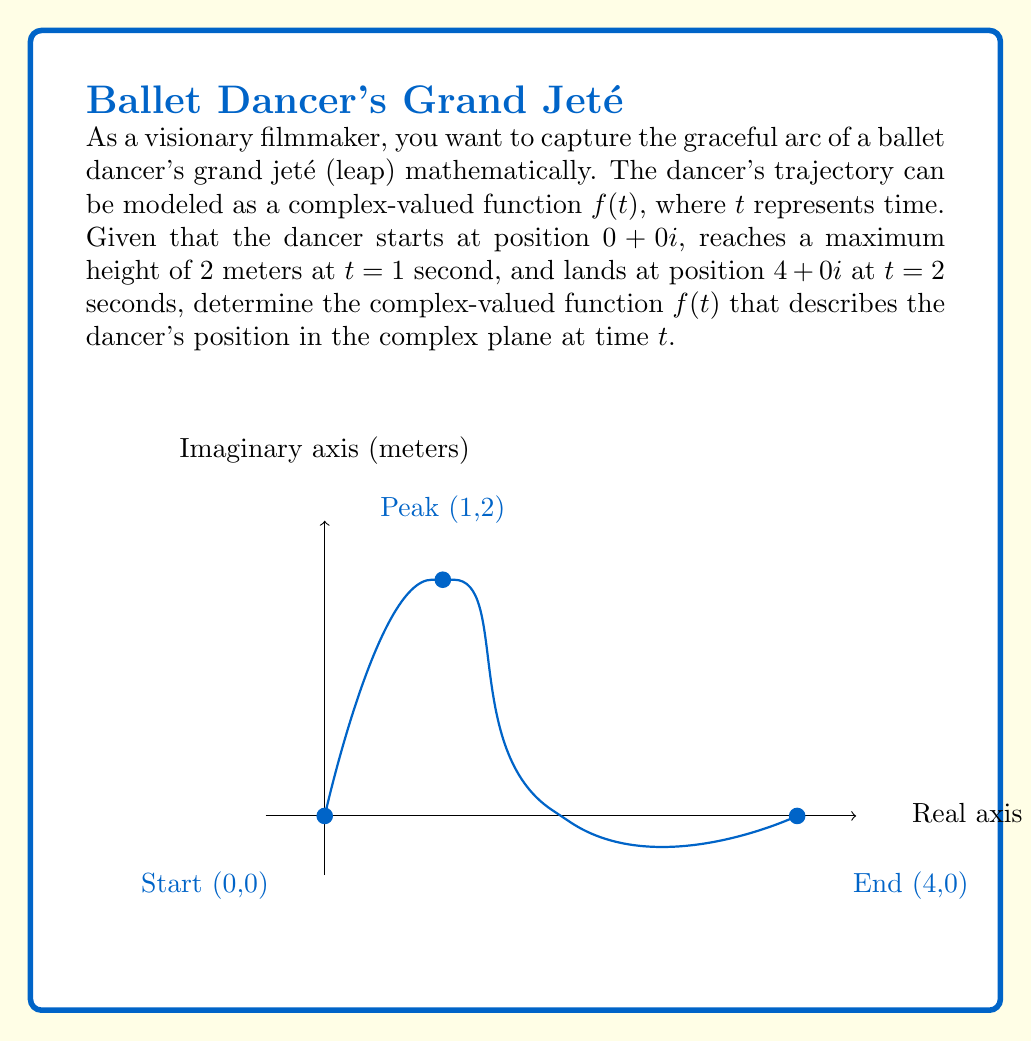Solve this math problem. Let's approach this step-by-step:

1) The real part of the function represents the horizontal position, and the imaginary part represents the vertical position.

2) For the horizontal motion, we have:
   - At $t=0$, $\text{Re}(f(0)) = 0$
   - At $t=2$, $\text{Re}(f(2)) = 4$
   This suggests linear motion: $\text{Re}(f(t)) = 2t$

3) For the vertical motion, we have a parabolic trajectory:
   - At $t=0$, $\text{Im}(f(0)) = 0$
   - At $t=1$, $\text{Im}(f(1)) = 2$ (peak)
   - At $t=2$, $\text{Im}(f(2)) = 0$

4) The general form of a parabola that passes through (0,0), (1,2), and (2,0) is:
   $\text{Im}(f(t)) = at^2 + bt$

5) Substituting the known points:
   $0 = a(0)^2 + b(0)$
   $2 = a(1)^2 + b(1)$
   $0 = a(2)^2 + b(2)$

6) From the second equation: $2 = a + b$
   From the third equation: $0 = 4a + 2b$

7) Solving these simultaneously:
   $a = -2$ and $b = 4$

8) Therefore, $\text{Im}(f(t)) = -2t^2 + 4t$

9) Combining the real and imaginary parts:
   $f(t) = 2t + (-2t^2 + 4t)i$

10) Simplifying:
    $f(t) = 2t + (-2t^2 + 4t)i$
Answer: $f(t) = 2t + (-2t^2 + 4t)i$ 